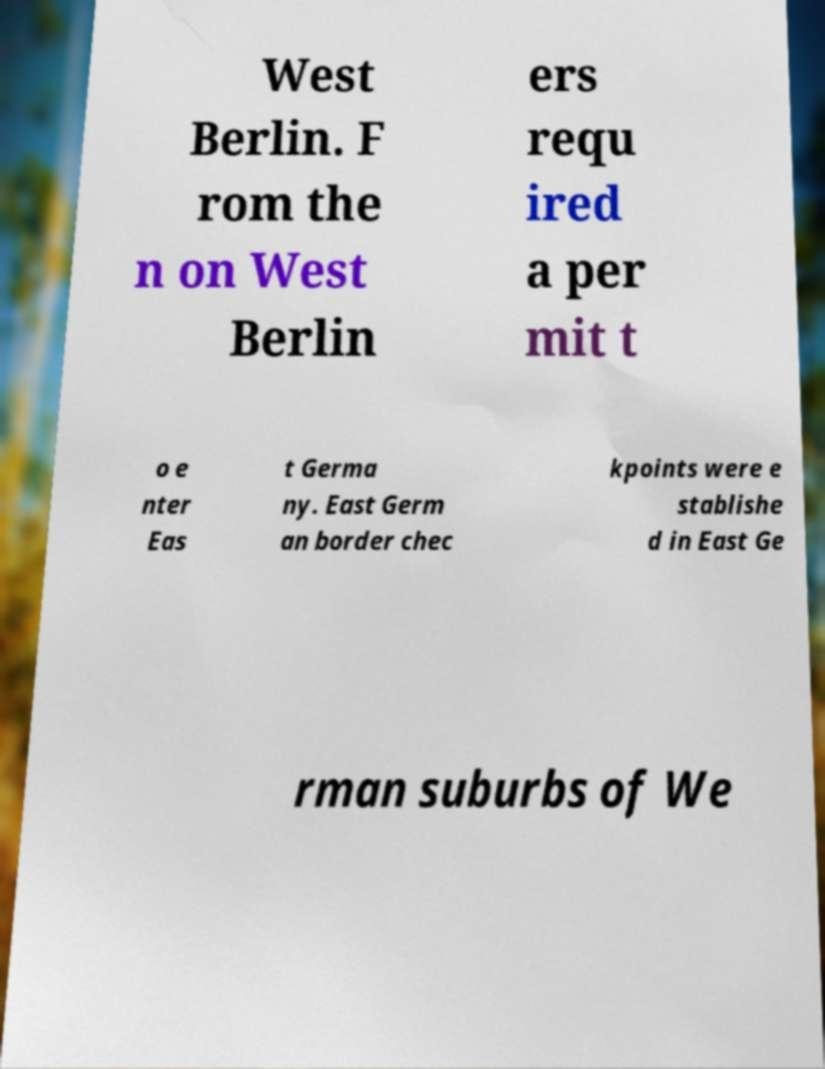Please identify and transcribe the text found in this image. West Berlin. F rom the n on West Berlin ers requ ired a per mit t o e nter Eas t Germa ny. East Germ an border chec kpoints were e stablishe d in East Ge rman suburbs of We 